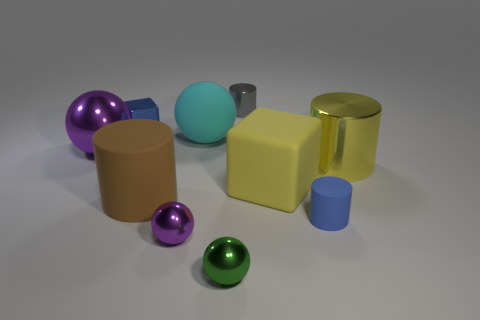Subtract all balls. How many objects are left? 6 Add 6 tiny cylinders. How many tiny cylinders exist? 8 Subtract 0 gray spheres. How many objects are left? 10 Subtract all big gray rubber cubes. Subtract all large brown cylinders. How many objects are left? 9 Add 7 big cylinders. How many big cylinders are left? 9 